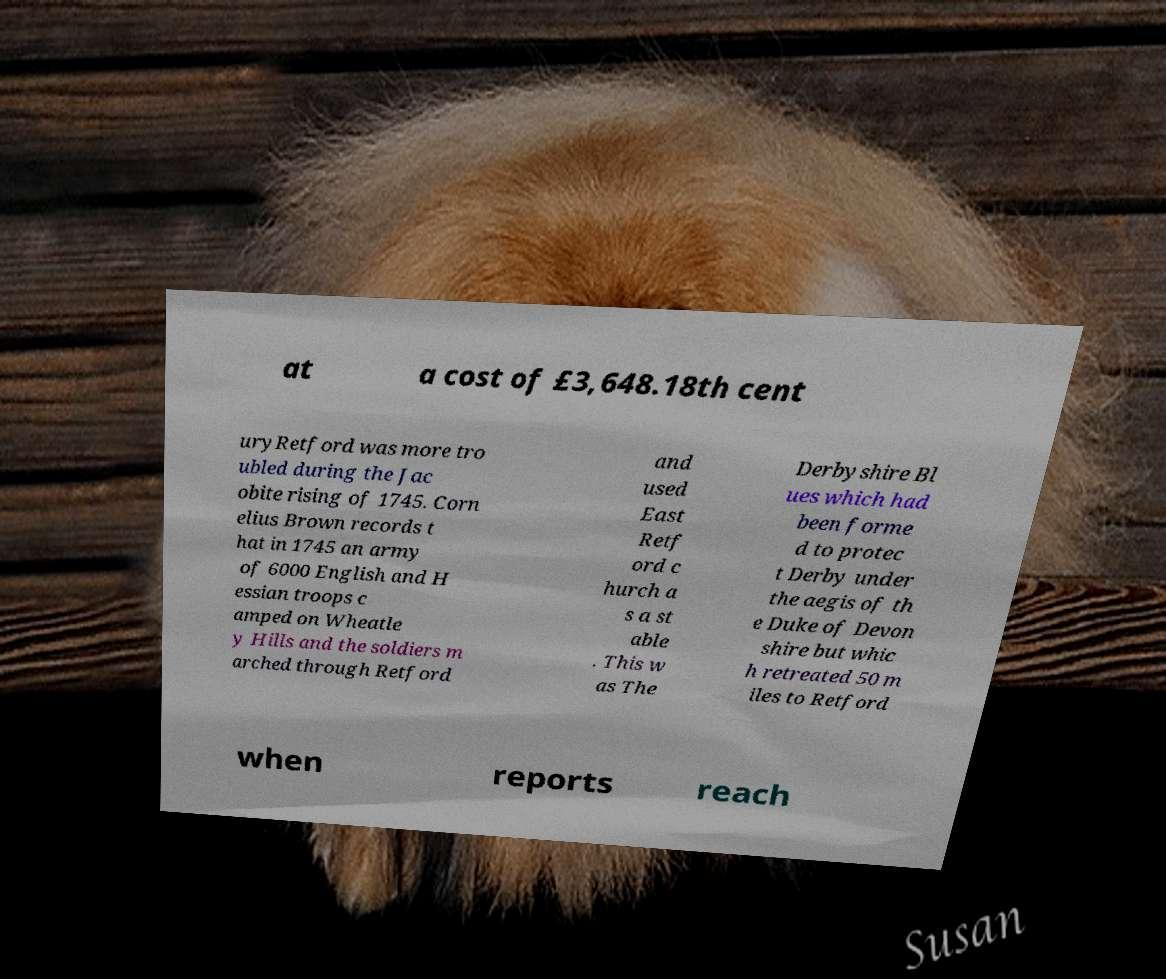What messages or text are displayed in this image? I need them in a readable, typed format. at a cost of £3,648.18th cent uryRetford was more tro ubled during the Jac obite rising of 1745. Corn elius Brown records t hat in 1745 an army of 6000 English and H essian troops c amped on Wheatle y Hills and the soldiers m arched through Retford and used East Retf ord c hurch a s a st able . This w as The Derbyshire Bl ues which had been forme d to protec t Derby under the aegis of th e Duke of Devon shire but whic h retreated 50 m iles to Retford when reports reach 